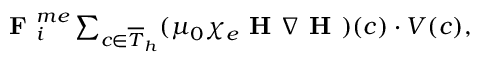<formula> <loc_0><loc_0><loc_500><loc_500>\begin{array} { r } { F _ { i } ^ { m e } \sum _ { c \in \overline { T } _ { h } } ( \mu _ { 0 } \chi _ { e } H \nabla H ) ( c ) \cdot V ( c ) , } \end{array}</formula> 